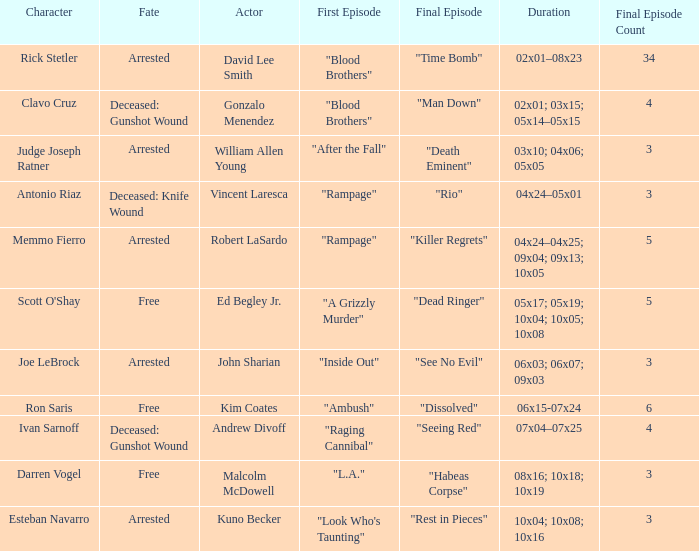What's the actor with character being judge joseph ratner William Allen Young. 